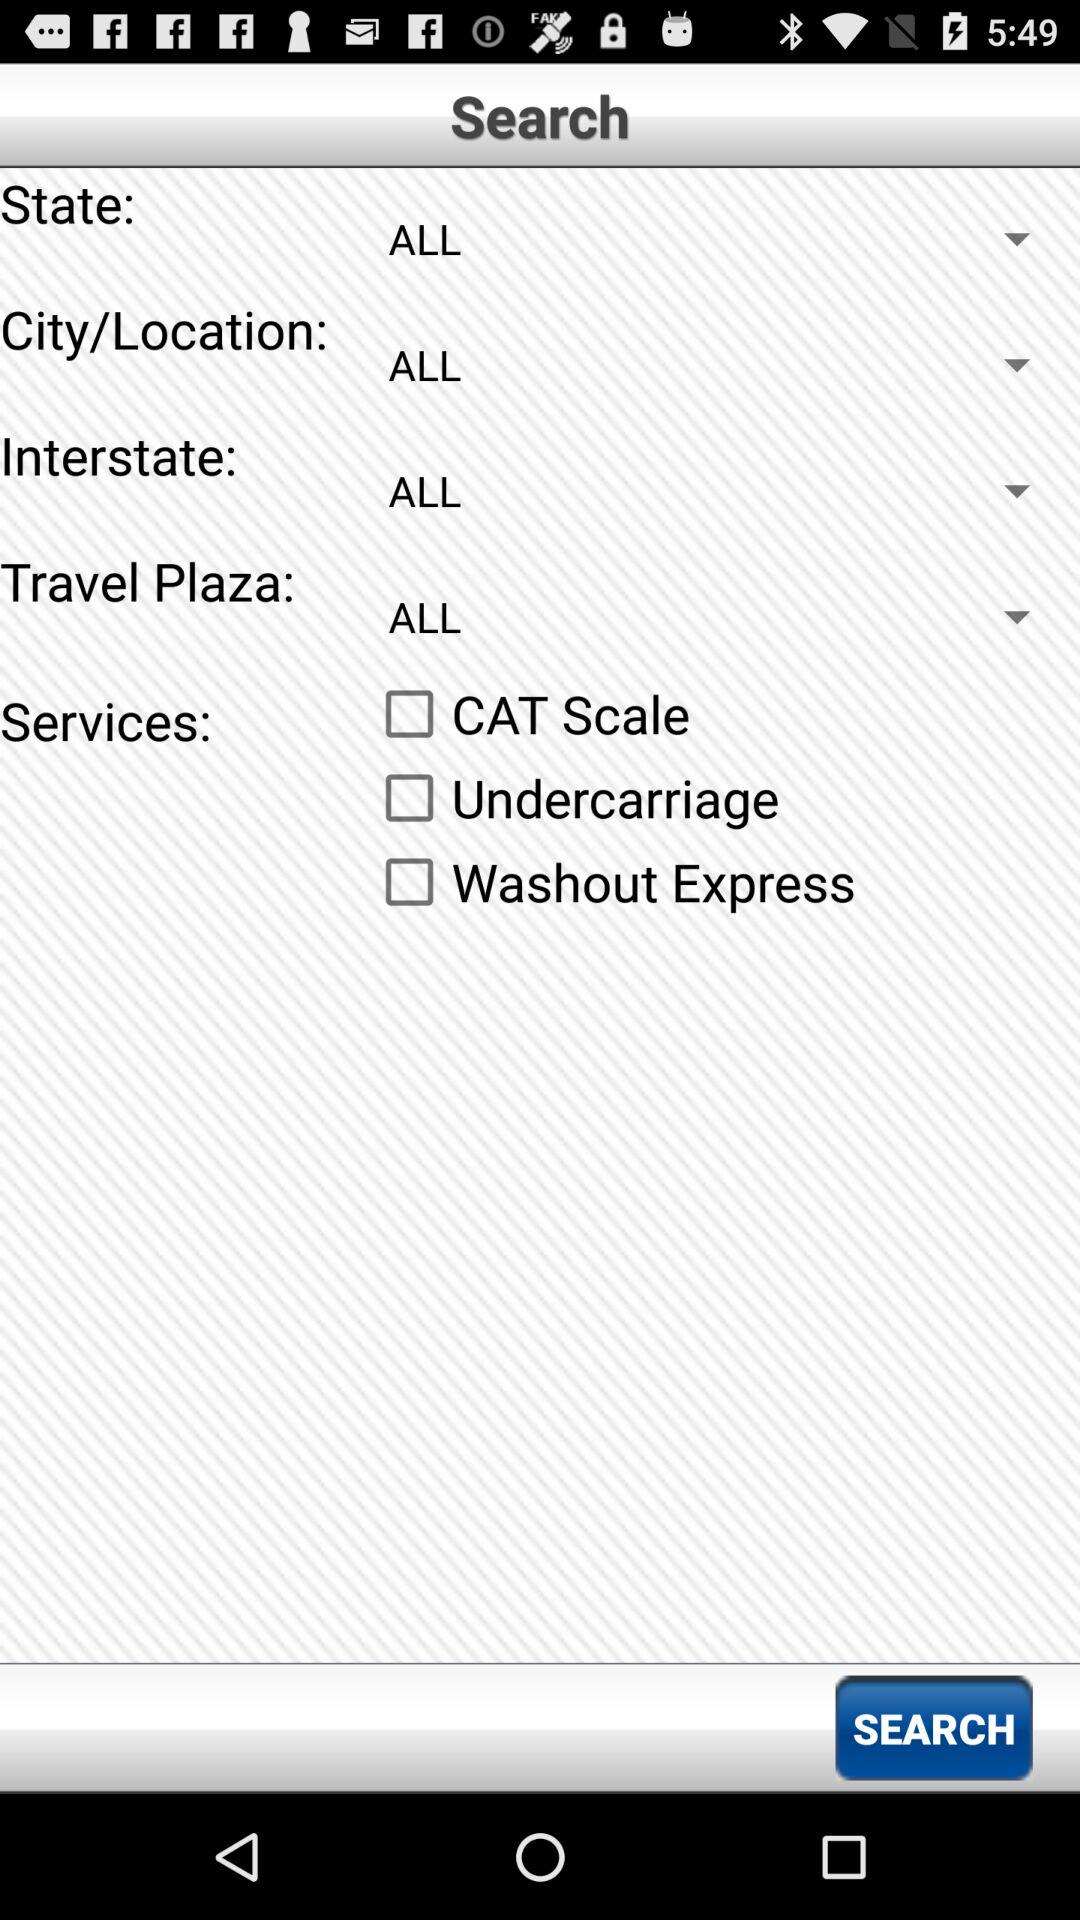Which travel plaza is selected? The selected travel plaza is "ALL". 